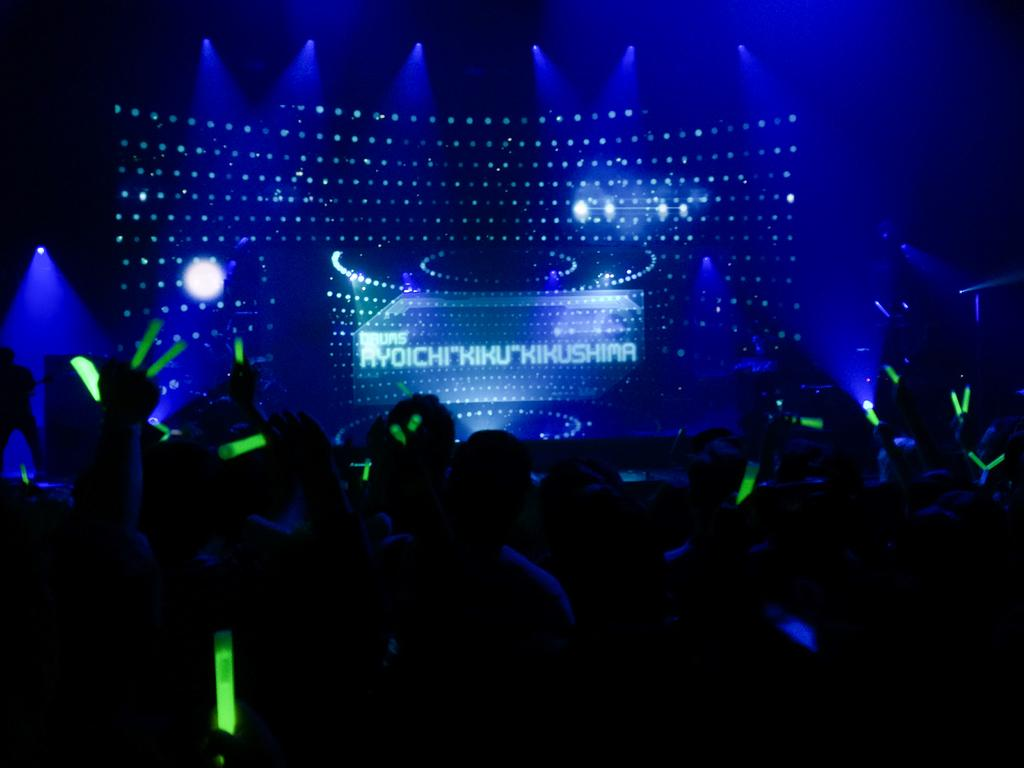Who is present in the image? There are people in the image. What type of lighting is present in the image? The people are in disco lights. What can be seen in the background of the image? There is a stage in the image. How many babies are holding hands and joining the people on stage in the image? There are no babies present in the image, and the people are not holding hands. 